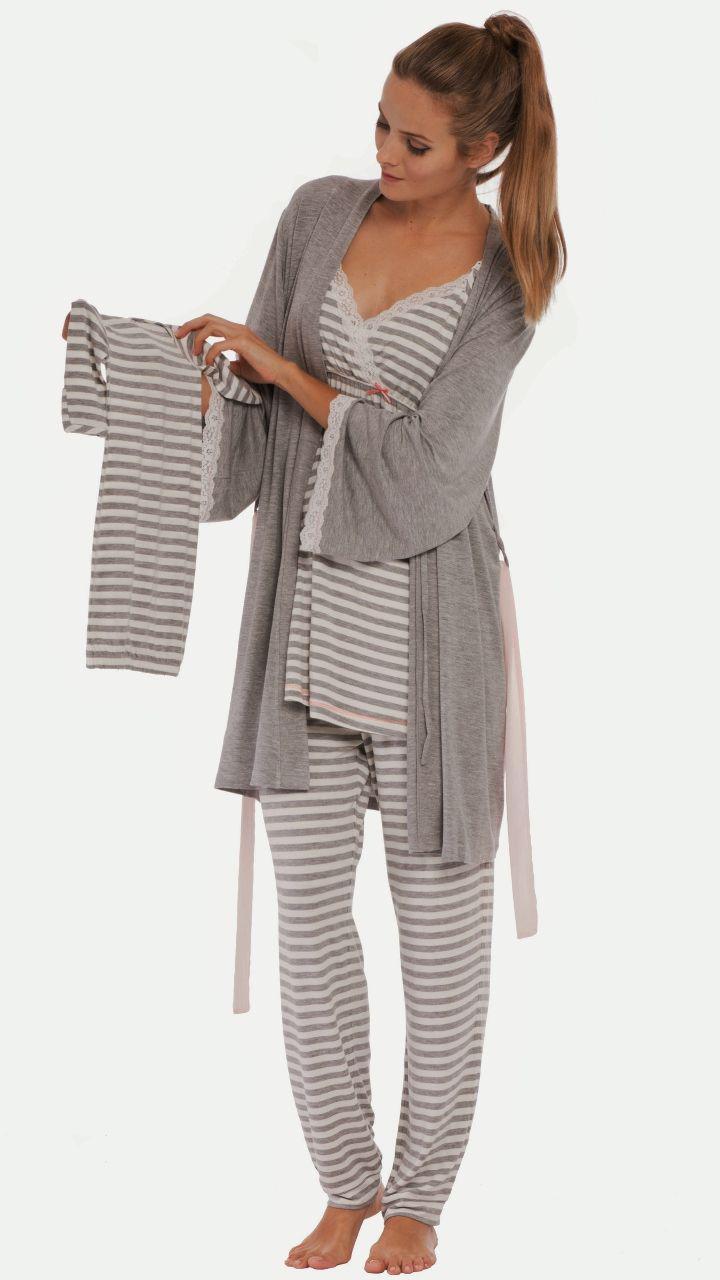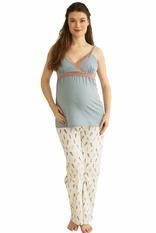The first image is the image on the left, the second image is the image on the right. For the images shown, is this caption "In at least 1 of the images, 1 person is wearing patterned white pants." true? Answer yes or no. Yes. The first image is the image on the left, the second image is the image on the right. For the images shown, is this caption "One women's pajama outfit has a matching short robe." true? Answer yes or no. Yes. 